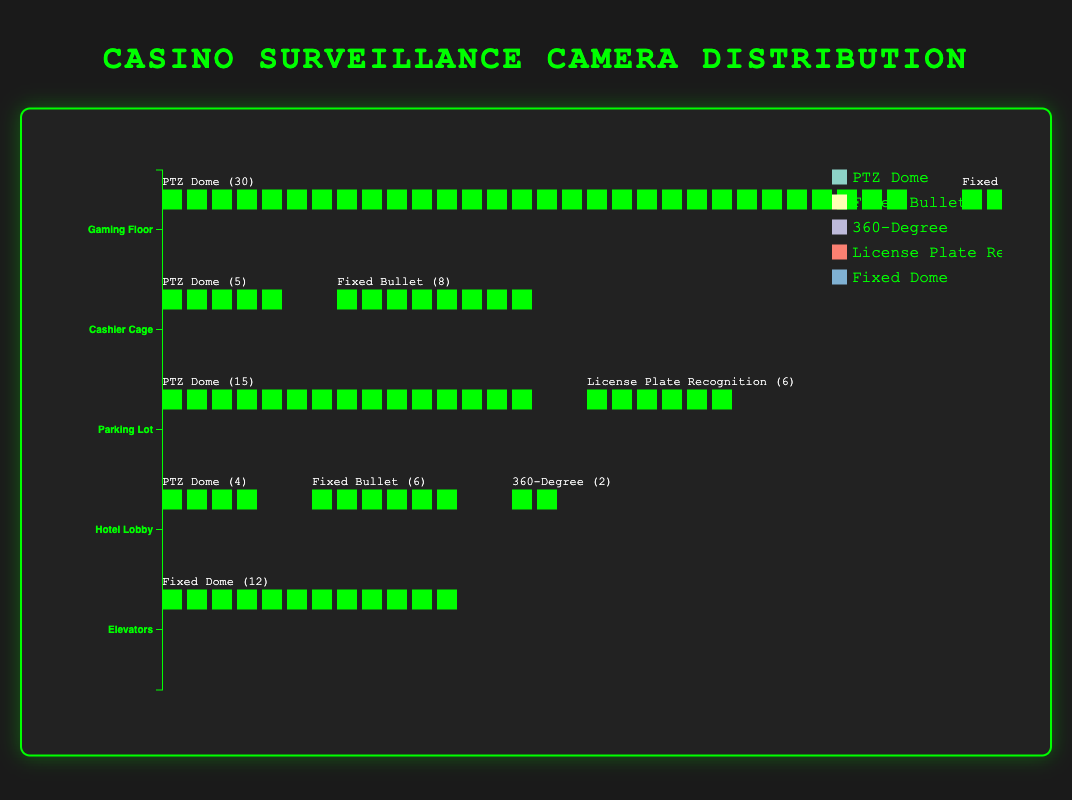What is the most common type of camera on the gaming floor? The figure shows three types of cameras on the gaming floor: PTZ Dome (30), Fixed Bullet (25), and 360-Degree (10). The PTZ Dome camera has the highest count of 30.
Answer: PTZ Dome How many 360-Degree cameras are there in total across all areas? The 360-Degree cameras are present in two areas: Gaming Floor (10) and Hotel Lobby (2). Summing these gives a total of 10 + 2 = 12.
Answer: 12 Which area has the highest overall number of cameras? By examining the counts of cameras for each area: Gaming Floor (30+25+10=65), Cashier Cage (5+8=13), Parking Lot (15+6=21), Hotel Lobby (4+6+2=12), and Elevators (12). The Gaming Floor has the highest total of 65 cameras.
Answer: Gaming Floor What is the total number of PTZ Dome cameras across all areas? Summing up the PTZ Dome cameras in all areas: Gaming Floor (30), Cashier Cage (5), Parking Lot (15), and Hotel Lobby (4). The total is 30 + 5 + 15 + 4 = 54.
Answer: 54 Which type of camera is exclusively found in one area? The License Plate Recognition camera is the only type found exclusively in the Parking Lot (6).
Answer: License Plate Recognition Are there more Fixed Bullet cameras or Fixed Dome cameras across all areas? There are Fixed Bullet cameras in the Gaming Floor (25), Cashier Cage (8), and Hotel Lobby (6), summing to 25 + 8 + 6 = 39. The Fixed Dome cameras are only in the Elevators (12). Thus, there are more Fixed Bullet cameras (39) than Fixed Dome cameras (12).
Answer: Fixed Bullet Which area has the fewest total cameras? By looking at each area: Gaming Floor (65), Cashier Cage (13), Parking Lot (21), Hotel Lobby (12), and Elevators (12), both Hotel Lobby and Elevators have the fewest with 12 cameras.
Answer: Hotel Lobby and Elevators How many different types of cameras are used in the entire casino? The figure displays PTZ Dome, Fixed Bullet, 360-Degree, License Plate Recognition, and Fixed Dome cameras, totaling 5 different types.
Answer: 5 Which area has the least variety in camera types? The Elevators only have one type of camera, which is the Fixed Dome (12). This is the least variety among all areas.
Answer: Elevators 